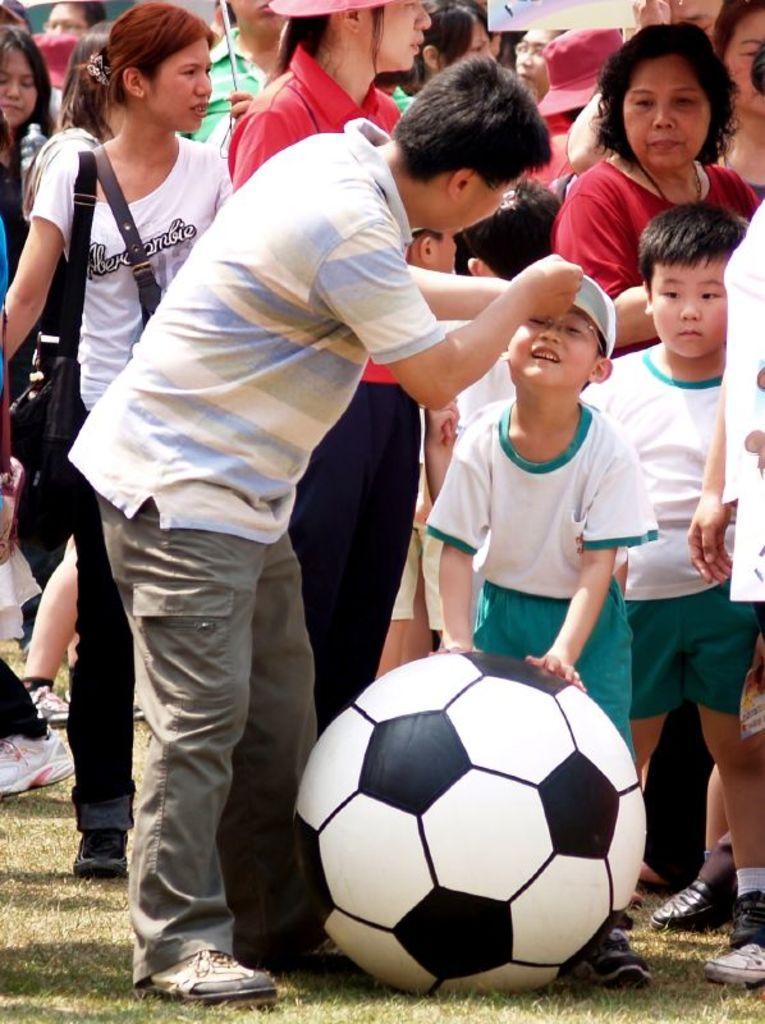Please provide a concise description of this image. In this image I can see lot of people on the grass and there is a boy who is with the ball. 